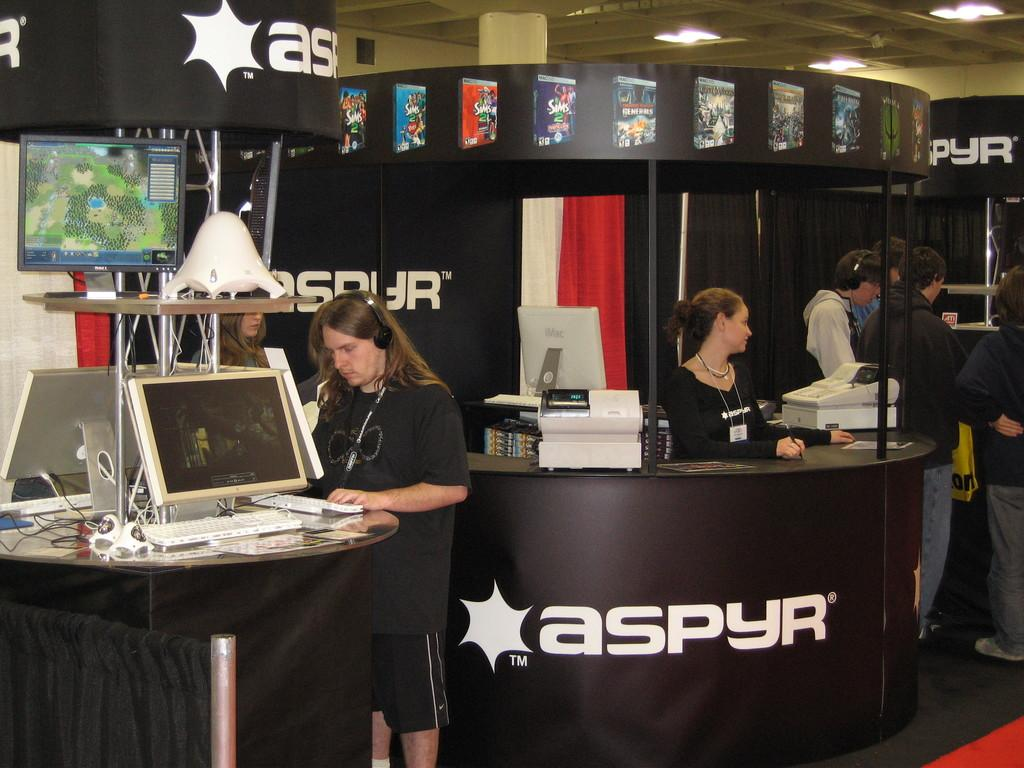Who is the main subject in the image? There is a person in the image. What is the person wearing? The person is wearing a black shirt. What is the person doing in the image? The person is operating a computer. Can you describe the people behind the person? There is a group of people behind the person. What type of bread is the person cooking in the image? There is no bread or cooking activity present in the image. In which direction is the person facing in the image? The provided facts do not specify the direction the person is facing in the image. 